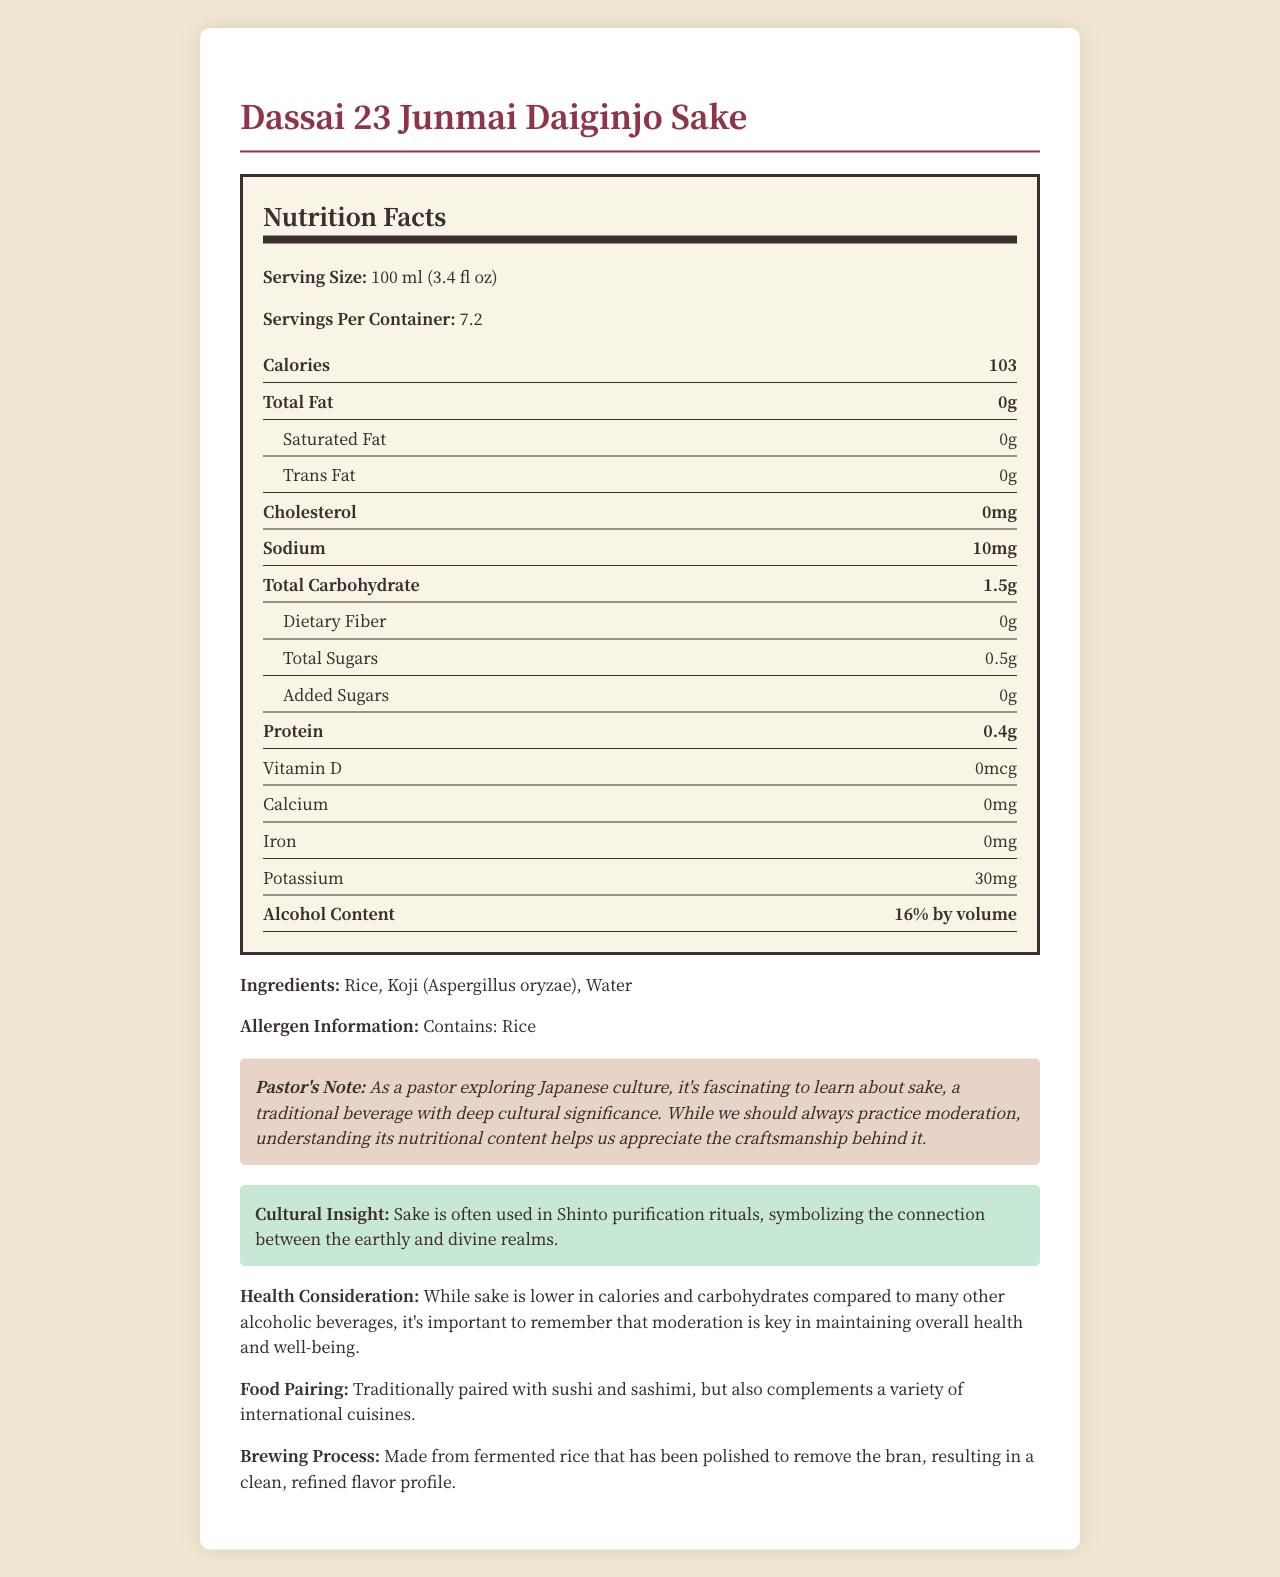what is the serving size? The serving size is explicitly mentioned in the nutrition facts section.
Answer: 100 ml (3.4 fl oz) how many servings are in the container? The document clearly states that there are 7.2 servings per container.
Answer: 7.2 what is the calorie content per serving? The document specifies that each serving contains 103 calories.
Answer: 103 calories how much total carbohydrate is in a serving? The total carbohydrate content per serving is listed as 1.5 grams.
Answer: 1.5g how much protein does one serving contain? The document mentions that one serving contains 0.4 grams of protein.
Answer: 0.4g what is the main ingredient in the sake? A. Water B. Koji C. Rice The ingredients section lists Rice, Koji, and Water, with rice being the primary ingredient.
Answer: C. Rice how much sodium is in a single serving of the sake? A. 0 mg B. 10 mg C. 30 mg D. 50 mg The nutrition label indicates that there are 10 mg of sodium per serving.
Answer: B. 10 mg what is the alcohol content by volume? The alcohol content is specified as 16% by volume.
Answer: 16% does this sake contain any added sugars? The document states that there are 0 grams of added sugars.
Answer: No is sake lower in calories compared to many other alcoholic beverages? The pastor's note mentions that sake is lower in calories and carbohydrates compared to many other alcoholic beverages.
Answer: Yes briefly summarize the main elements of the document. The summary captures key points such as nutritional details, cultural significance, and recommendations for consumption.
Answer: The document provides a detailed nutrition facts label for Dassai 23 Junmai Daiginjo Sake, showcasing calories, carbohydrate content, and other nutritional information per 100 ml serving. It also includes cultural insights, a pastor's note on moderation, health considerations, food pairing suggestions, and information on the brewing process. what is the potassium content per serving? The document lists the potassium content as 30 mg per serving.
Answer: 30 mg how much saturated fat is in a serving? The document explicitly states that there are 0 grams of saturated fat in a serving.
Answer: 0g what is the cultural significance of sake mentioned in the document? The cultural insight section mentions that sake is used in Shinto rituals for purification.
Answer: Sake is often used in Shinto purification rituals, symbolizing the connection between the earthly and divine realms. how is the sake traditionally paired with food? The food pairing section states that sake is paired with sushi and sashimi and complements various international cuisines.
Answer: Traditionally paired with sushi and sashimi, but also complements a variety of international cuisines. how much dietary fiber does one serving contain? The document specifies that there is 0 grams of dietary fiber per serving.
Answer: 0g how does the pastor describe the importance of understanding sake's nutritional content? The pastor's note mentions that learning the nutritional content aids in appreciating the craftsmanship of sake.
Answer: Understanding its nutritional content helps us appreciate the craftsmanship behind it. what is the brewing process for the Dassai 23 Junmai Daiginjo Sake? The brewing process section explains that the sake is made from polished rice which results in a refined flavor.
Answer: Made from fermented rice that has been polished to remove the bran, resulting in a clean, refined flavor profile. how much calcium is in one serving of sake? The document lists calcium content as 0 mg per serving.
Answer: 0mg how much iron is in each serving? The document notes that there is 0 mg of iron per serving.
Answer: 0mg does the document provide specific health benefits of drinking sake? The document emphasizes moderation and lower calorie content, but it does not provide specific health benefits.
Answer: Not enough information what are the allergens present in this sake? The allergen information section mentions that the product contains rice.
Answer: Contains: Rice 